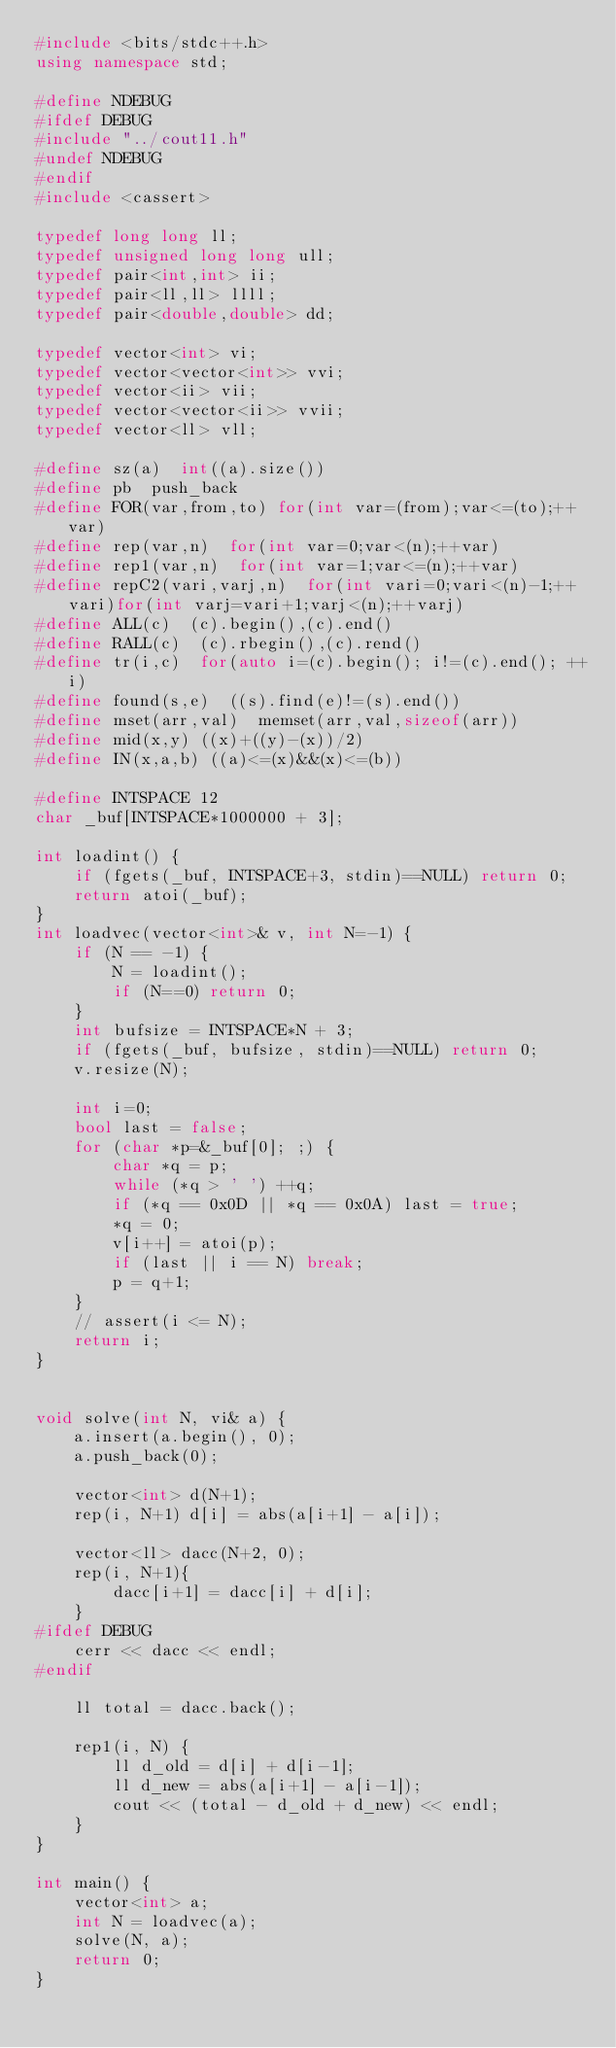<code> <loc_0><loc_0><loc_500><loc_500><_C++_>#include <bits/stdc++.h>
using namespace std;

#define NDEBUG
#ifdef DEBUG
#include "../cout11.h"
#undef NDEBUG
#endif
#include <cassert>

typedef long long ll;
typedef unsigned long long ull;
typedef pair<int,int> ii;
typedef pair<ll,ll> llll;
typedef pair<double,double> dd;

typedef vector<int> vi;
typedef vector<vector<int>> vvi;
typedef vector<ii> vii;
typedef vector<vector<ii>> vvii;
typedef vector<ll> vll;

#define sz(a)  int((a).size())
#define pb  push_back
#define FOR(var,from,to) for(int var=(from);var<=(to);++var)
#define rep(var,n)  for(int var=0;var<(n);++var)
#define rep1(var,n)  for(int var=1;var<=(n);++var)
#define repC2(vari,varj,n)  for(int vari=0;vari<(n)-1;++vari)for(int varj=vari+1;varj<(n);++varj)
#define ALL(c)  (c).begin(),(c).end()
#define RALL(c)  (c).rbegin(),(c).rend()
#define tr(i,c)  for(auto i=(c).begin(); i!=(c).end(); ++i)
#define found(s,e)  ((s).find(e)!=(s).end())
#define mset(arr,val)  memset(arr,val,sizeof(arr))
#define mid(x,y) ((x)+((y)-(x))/2)
#define IN(x,a,b) ((a)<=(x)&&(x)<=(b))

#define INTSPACE 12
char _buf[INTSPACE*1000000 + 3];

int loadint() {
    if (fgets(_buf, INTSPACE+3, stdin)==NULL) return 0;
    return atoi(_buf);
}
int loadvec(vector<int>& v, int N=-1) {
    if (N == -1) {
        N = loadint();
        if (N==0) return 0;
    }
    int bufsize = INTSPACE*N + 3;
    if (fgets(_buf, bufsize, stdin)==NULL) return 0;
    v.resize(N);

    int i=0;
    bool last = false;
    for (char *p=&_buf[0]; ;) {
        char *q = p;
        while (*q > ' ') ++q;
        if (*q == 0x0D || *q == 0x0A) last = true;
        *q = 0;
        v[i++] = atoi(p);
        if (last || i == N) break;
        p = q+1;
    }
    // assert(i <= N);
    return i;
}


void solve(int N, vi& a) {
    a.insert(a.begin(), 0);
    a.push_back(0);

    vector<int> d(N+1);
    rep(i, N+1) d[i] = abs(a[i+1] - a[i]);

    vector<ll> dacc(N+2, 0);
    rep(i, N+1){
        dacc[i+1] = dacc[i] + d[i];
    }
#ifdef DEBUG
    cerr << dacc << endl;
#endif

    ll total = dacc.back();

    rep1(i, N) {
        ll d_old = d[i] + d[i-1];
        ll d_new = abs(a[i+1] - a[i-1]);
        cout << (total - d_old + d_new) << endl;
    }
}

int main() {
    vector<int> a;
    int N = loadvec(a);
    solve(N, a);
    return 0;
}
</code> 